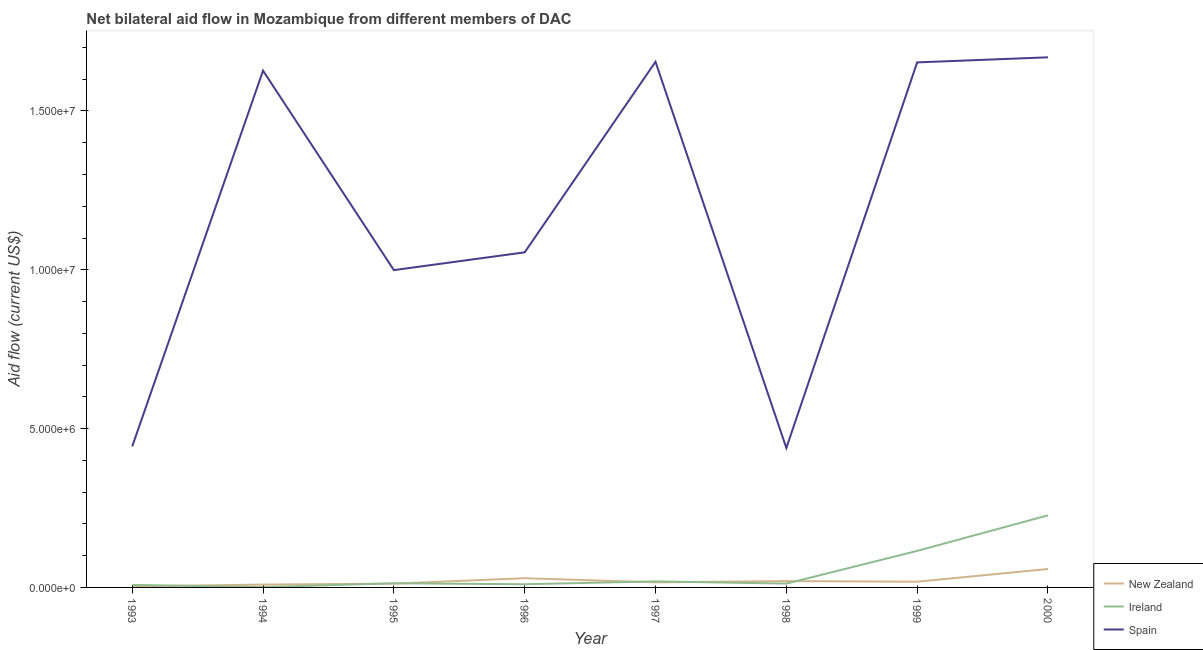Does the line corresponding to amount of aid provided by ireland intersect with the line corresponding to amount of aid provided by spain?
Make the answer very short. No. Is the number of lines equal to the number of legend labels?
Your answer should be compact. Yes. What is the amount of aid provided by spain in 1999?
Ensure brevity in your answer.  1.65e+07. Across all years, what is the maximum amount of aid provided by spain?
Your response must be concise. 1.67e+07. Across all years, what is the minimum amount of aid provided by new zealand?
Ensure brevity in your answer.  3.00e+04. In which year was the amount of aid provided by spain maximum?
Ensure brevity in your answer.  2000. In which year was the amount of aid provided by new zealand minimum?
Provide a succinct answer. 1993. What is the total amount of aid provided by ireland in the graph?
Your answer should be compact. 4.05e+06. What is the difference between the amount of aid provided by spain in 1994 and that in 1997?
Your answer should be compact. -2.80e+05. What is the difference between the amount of aid provided by new zealand in 1999 and the amount of aid provided by ireland in 1996?
Your answer should be very brief. 8.00e+04. What is the average amount of aid provided by spain per year?
Keep it short and to the point. 1.19e+07. In the year 1996, what is the difference between the amount of aid provided by new zealand and amount of aid provided by ireland?
Offer a terse response. 1.90e+05. What is the ratio of the amount of aid provided by spain in 1998 to that in 2000?
Offer a terse response. 0.26. Is the difference between the amount of aid provided by new zealand in 1993 and 1994 greater than the difference between the amount of aid provided by ireland in 1993 and 1994?
Offer a terse response. No. What is the difference between the highest and the lowest amount of aid provided by spain?
Ensure brevity in your answer.  1.23e+07. In how many years, is the amount of aid provided by spain greater than the average amount of aid provided by spain taken over all years?
Your answer should be very brief. 4. Is it the case that in every year, the sum of the amount of aid provided by new zealand and amount of aid provided by ireland is greater than the amount of aid provided by spain?
Provide a succinct answer. No. How many years are there in the graph?
Your answer should be very brief. 8. What is the difference between two consecutive major ticks on the Y-axis?
Make the answer very short. 5.00e+06. How many legend labels are there?
Your answer should be compact. 3. What is the title of the graph?
Keep it short and to the point. Net bilateral aid flow in Mozambique from different members of DAC. Does "Tertiary education" appear as one of the legend labels in the graph?
Give a very brief answer. No. What is the label or title of the Y-axis?
Provide a succinct answer. Aid flow (current US$). What is the Aid flow (current US$) of Spain in 1993?
Offer a terse response. 4.44e+06. What is the Aid flow (current US$) of New Zealand in 1994?
Make the answer very short. 9.00e+04. What is the Aid flow (current US$) in Spain in 1994?
Your answer should be very brief. 1.63e+07. What is the Aid flow (current US$) in New Zealand in 1995?
Your response must be concise. 1.20e+05. What is the Aid flow (current US$) of Spain in 1995?
Ensure brevity in your answer.  9.99e+06. What is the Aid flow (current US$) of Spain in 1996?
Keep it short and to the point. 1.06e+07. What is the Aid flow (current US$) of Spain in 1997?
Keep it short and to the point. 1.66e+07. What is the Aid flow (current US$) in New Zealand in 1998?
Offer a very short reply. 2.00e+05. What is the Aid flow (current US$) in Spain in 1998?
Offer a terse response. 4.39e+06. What is the Aid flow (current US$) in Ireland in 1999?
Offer a terse response. 1.15e+06. What is the Aid flow (current US$) of Spain in 1999?
Keep it short and to the point. 1.65e+07. What is the Aid flow (current US$) in New Zealand in 2000?
Give a very brief answer. 5.80e+05. What is the Aid flow (current US$) in Ireland in 2000?
Your answer should be very brief. 2.27e+06. What is the Aid flow (current US$) in Spain in 2000?
Provide a succinct answer. 1.67e+07. Across all years, what is the maximum Aid flow (current US$) in New Zealand?
Provide a succinct answer. 5.80e+05. Across all years, what is the maximum Aid flow (current US$) of Ireland?
Your answer should be very brief. 2.27e+06. Across all years, what is the maximum Aid flow (current US$) in Spain?
Your response must be concise. 1.67e+07. Across all years, what is the minimum Aid flow (current US$) of Spain?
Your answer should be compact. 4.39e+06. What is the total Aid flow (current US$) in New Zealand in the graph?
Provide a succinct answer. 1.65e+06. What is the total Aid flow (current US$) of Ireland in the graph?
Provide a short and direct response. 4.05e+06. What is the total Aid flow (current US$) of Spain in the graph?
Ensure brevity in your answer.  9.54e+07. What is the difference between the Aid flow (current US$) of Spain in 1993 and that in 1994?
Provide a short and direct response. -1.18e+07. What is the difference between the Aid flow (current US$) in Ireland in 1993 and that in 1995?
Provide a short and direct response. -5.00e+04. What is the difference between the Aid flow (current US$) in Spain in 1993 and that in 1995?
Make the answer very short. -5.55e+06. What is the difference between the Aid flow (current US$) of Spain in 1993 and that in 1996?
Give a very brief answer. -6.11e+06. What is the difference between the Aid flow (current US$) in Ireland in 1993 and that in 1997?
Your answer should be very brief. -1.10e+05. What is the difference between the Aid flow (current US$) of Spain in 1993 and that in 1997?
Provide a short and direct response. -1.21e+07. What is the difference between the Aid flow (current US$) in New Zealand in 1993 and that in 1998?
Offer a very short reply. -1.70e+05. What is the difference between the Aid flow (current US$) of Ireland in 1993 and that in 1998?
Give a very brief answer. -4.00e+04. What is the difference between the Aid flow (current US$) in Ireland in 1993 and that in 1999?
Provide a succinct answer. -1.07e+06. What is the difference between the Aid flow (current US$) in Spain in 1993 and that in 1999?
Ensure brevity in your answer.  -1.21e+07. What is the difference between the Aid flow (current US$) in New Zealand in 1993 and that in 2000?
Provide a short and direct response. -5.50e+05. What is the difference between the Aid flow (current US$) of Ireland in 1993 and that in 2000?
Ensure brevity in your answer.  -2.19e+06. What is the difference between the Aid flow (current US$) of Spain in 1993 and that in 2000?
Offer a terse response. -1.22e+07. What is the difference between the Aid flow (current US$) in New Zealand in 1994 and that in 1995?
Offer a very short reply. -3.00e+04. What is the difference between the Aid flow (current US$) of Ireland in 1994 and that in 1995?
Offer a terse response. -1.20e+05. What is the difference between the Aid flow (current US$) of Spain in 1994 and that in 1995?
Your answer should be very brief. 6.28e+06. What is the difference between the Aid flow (current US$) of Spain in 1994 and that in 1996?
Provide a succinct answer. 5.72e+06. What is the difference between the Aid flow (current US$) in New Zealand in 1994 and that in 1997?
Offer a very short reply. -7.00e+04. What is the difference between the Aid flow (current US$) in Spain in 1994 and that in 1997?
Your answer should be compact. -2.80e+05. What is the difference between the Aid flow (current US$) of Ireland in 1994 and that in 1998?
Provide a succinct answer. -1.10e+05. What is the difference between the Aid flow (current US$) of Spain in 1994 and that in 1998?
Make the answer very short. 1.19e+07. What is the difference between the Aid flow (current US$) in Ireland in 1994 and that in 1999?
Offer a terse response. -1.14e+06. What is the difference between the Aid flow (current US$) in New Zealand in 1994 and that in 2000?
Keep it short and to the point. -4.90e+05. What is the difference between the Aid flow (current US$) of Ireland in 1994 and that in 2000?
Your response must be concise. -2.26e+06. What is the difference between the Aid flow (current US$) of Spain in 1994 and that in 2000?
Your response must be concise. -4.20e+05. What is the difference between the Aid flow (current US$) of Spain in 1995 and that in 1996?
Give a very brief answer. -5.60e+05. What is the difference between the Aid flow (current US$) in New Zealand in 1995 and that in 1997?
Offer a terse response. -4.00e+04. What is the difference between the Aid flow (current US$) in Ireland in 1995 and that in 1997?
Ensure brevity in your answer.  -6.00e+04. What is the difference between the Aid flow (current US$) in Spain in 1995 and that in 1997?
Provide a succinct answer. -6.56e+06. What is the difference between the Aid flow (current US$) of New Zealand in 1995 and that in 1998?
Make the answer very short. -8.00e+04. What is the difference between the Aid flow (current US$) in Spain in 1995 and that in 1998?
Offer a very short reply. 5.60e+06. What is the difference between the Aid flow (current US$) in Ireland in 1995 and that in 1999?
Provide a short and direct response. -1.02e+06. What is the difference between the Aid flow (current US$) in Spain in 1995 and that in 1999?
Your answer should be very brief. -6.54e+06. What is the difference between the Aid flow (current US$) of New Zealand in 1995 and that in 2000?
Your answer should be compact. -4.60e+05. What is the difference between the Aid flow (current US$) of Ireland in 1995 and that in 2000?
Provide a short and direct response. -2.14e+06. What is the difference between the Aid flow (current US$) in Spain in 1995 and that in 2000?
Make the answer very short. -6.70e+06. What is the difference between the Aid flow (current US$) in New Zealand in 1996 and that in 1997?
Give a very brief answer. 1.30e+05. What is the difference between the Aid flow (current US$) in Spain in 1996 and that in 1997?
Your answer should be compact. -6.00e+06. What is the difference between the Aid flow (current US$) in Spain in 1996 and that in 1998?
Your response must be concise. 6.16e+06. What is the difference between the Aid flow (current US$) of New Zealand in 1996 and that in 1999?
Provide a succinct answer. 1.10e+05. What is the difference between the Aid flow (current US$) in Ireland in 1996 and that in 1999?
Your answer should be very brief. -1.05e+06. What is the difference between the Aid flow (current US$) of Spain in 1996 and that in 1999?
Make the answer very short. -5.98e+06. What is the difference between the Aid flow (current US$) of Ireland in 1996 and that in 2000?
Your answer should be very brief. -2.17e+06. What is the difference between the Aid flow (current US$) of Spain in 1996 and that in 2000?
Offer a very short reply. -6.14e+06. What is the difference between the Aid flow (current US$) in New Zealand in 1997 and that in 1998?
Provide a short and direct response. -4.00e+04. What is the difference between the Aid flow (current US$) of Ireland in 1997 and that in 1998?
Make the answer very short. 7.00e+04. What is the difference between the Aid flow (current US$) of Spain in 1997 and that in 1998?
Keep it short and to the point. 1.22e+07. What is the difference between the Aid flow (current US$) in New Zealand in 1997 and that in 1999?
Give a very brief answer. -2.00e+04. What is the difference between the Aid flow (current US$) of Ireland in 1997 and that in 1999?
Offer a terse response. -9.60e+05. What is the difference between the Aid flow (current US$) in New Zealand in 1997 and that in 2000?
Make the answer very short. -4.20e+05. What is the difference between the Aid flow (current US$) in Ireland in 1997 and that in 2000?
Offer a terse response. -2.08e+06. What is the difference between the Aid flow (current US$) in New Zealand in 1998 and that in 1999?
Your answer should be compact. 2.00e+04. What is the difference between the Aid flow (current US$) in Ireland in 1998 and that in 1999?
Give a very brief answer. -1.03e+06. What is the difference between the Aid flow (current US$) of Spain in 1998 and that in 1999?
Offer a very short reply. -1.21e+07. What is the difference between the Aid flow (current US$) in New Zealand in 1998 and that in 2000?
Keep it short and to the point. -3.80e+05. What is the difference between the Aid flow (current US$) in Ireland in 1998 and that in 2000?
Make the answer very short. -2.15e+06. What is the difference between the Aid flow (current US$) of Spain in 1998 and that in 2000?
Provide a short and direct response. -1.23e+07. What is the difference between the Aid flow (current US$) of New Zealand in 1999 and that in 2000?
Make the answer very short. -4.00e+05. What is the difference between the Aid flow (current US$) of Ireland in 1999 and that in 2000?
Offer a terse response. -1.12e+06. What is the difference between the Aid flow (current US$) of Spain in 1999 and that in 2000?
Your response must be concise. -1.60e+05. What is the difference between the Aid flow (current US$) of New Zealand in 1993 and the Aid flow (current US$) of Spain in 1994?
Offer a terse response. -1.62e+07. What is the difference between the Aid flow (current US$) of Ireland in 1993 and the Aid flow (current US$) of Spain in 1994?
Your response must be concise. -1.62e+07. What is the difference between the Aid flow (current US$) of New Zealand in 1993 and the Aid flow (current US$) of Spain in 1995?
Provide a succinct answer. -9.96e+06. What is the difference between the Aid flow (current US$) of Ireland in 1993 and the Aid flow (current US$) of Spain in 1995?
Your answer should be compact. -9.91e+06. What is the difference between the Aid flow (current US$) of New Zealand in 1993 and the Aid flow (current US$) of Spain in 1996?
Your answer should be very brief. -1.05e+07. What is the difference between the Aid flow (current US$) in Ireland in 1993 and the Aid flow (current US$) in Spain in 1996?
Ensure brevity in your answer.  -1.05e+07. What is the difference between the Aid flow (current US$) of New Zealand in 1993 and the Aid flow (current US$) of Ireland in 1997?
Offer a terse response. -1.60e+05. What is the difference between the Aid flow (current US$) in New Zealand in 1993 and the Aid flow (current US$) in Spain in 1997?
Give a very brief answer. -1.65e+07. What is the difference between the Aid flow (current US$) in Ireland in 1993 and the Aid flow (current US$) in Spain in 1997?
Ensure brevity in your answer.  -1.65e+07. What is the difference between the Aid flow (current US$) of New Zealand in 1993 and the Aid flow (current US$) of Ireland in 1998?
Offer a terse response. -9.00e+04. What is the difference between the Aid flow (current US$) of New Zealand in 1993 and the Aid flow (current US$) of Spain in 1998?
Ensure brevity in your answer.  -4.36e+06. What is the difference between the Aid flow (current US$) in Ireland in 1993 and the Aid flow (current US$) in Spain in 1998?
Give a very brief answer. -4.31e+06. What is the difference between the Aid flow (current US$) of New Zealand in 1993 and the Aid flow (current US$) of Ireland in 1999?
Keep it short and to the point. -1.12e+06. What is the difference between the Aid flow (current US$) in New Zealand in 1993 and the Aid flow (current US$) in Spain in 1999?
Your response must be concise. -1.65e+07. What is the difference between the Aid flow (current US$) in Ireland in 1993 and the Aid flow (current US$) in Spain in 1999?
Give a very brief answer. -1.64e+07. What is the difference between the Aid flow (current US$) of New Zealand in 1993 and the Aid flow (current US$) of Ireland in 2000?
Keep it short and to the point. -2.24e+06. What is the difference between the Aid flow (current US$) in New Zealand in 1993 and the Aid flow (current US$) in Spain in 2000?
Provide a short and direct response. -1.67e+07. What is the difference between the Aid flow (current US$) in Ireland in 1993 and the Aid flow (current US$) in Spain in 2000?
Ensure brevity in your answer.  -1.66e+07. What is the difference between the Aid flow (current US$) of New Zealand in 1994 and the Aid flow (current US$) of Spain in 1995?
Your answer should be very brief. -9.90e+06. What is the difference between the Aid flow (current US$) in Ireland in 1994 and the Aid flow (current US$) in Spain in 1995?
Offer a terse response. -9.98e+06. What is the difference between the Aid flow (current US$) of New Zealand in 1994 and the Aid flow (current US$) of Spain in 1996?
Provide a succinct answer. -1.05e+07. What is the difference between the Aid flow (current US$) of Ireland in 1994 and the Aid flow (current US$) of Spain in 1996?
Offer a very short reply. -1.05e+07. What is the difference between the Aid flow (current US$) of New Zealand in 1994 and the Aid flow (current US$) of Ireland in 1997?
Your answer should be compact. -1.00e+05. What is the difference between the Aid flow (current US$) of New Zealand in 1994 and the Aid flow (current US$) of Spain in 1997?
Ensure brevity in your answer.  -1.65e+07. What is the difference between the Aid flow (current US$) of Ireland in 1994 and the Aid flow (current US$) of Spain in 1997?
Your response must be concise. -1.65e+07. What is the difference between the Aid flow (current US$) of New Zealand in 1994 and the Aid flow (current US$) of Ireland in 1998?
Offer a terse response. -3.00e+04. What is the difference between the Aid flow (current US$) of New Zealand in 1994 and the Aid flow (current US$) of Spain in 1998?
Offer a very short reply. -4.30e+06. What is the difference between the Aid flow (current US$) of Ireland in 1994 and the Aid flow (current US$) of Spain in 1998?
Ensure brevity in your answer.  -4.38e+06. What is the difference between the Aid flow (current US$) of New Zealand in 1994 and the Aid flow (current US$) of Ireland in 1999?
Your response must be concise. -1.06e+06. What is the difference between the Aid flow (current US$) of New Zealand in 1994 and the Aid flow (current US$) of Spain in 1999?
Give a very brief answer. -1.64e+07. What is the difference between the Aid flow (current US$) in Ireland in 1994 and the Aid flow (current US$) in Spain in 1999?
Your response must be concise. -1.65e+07. What is the difference between the Aid flow (current US$) in New Zealand in 1994 and the Aid flow (current US$) in Ireland in 2000?
Offer a terse response. -2.18e+06. What is the difference between the Aid flow (current US$) in New Zealand in 1994 and the Aid flow (current US$) in Spain in 2000?
Your response must be concise. -1.66e+07. What is the difference between the Aid flow (current US$) of Ireland in 1994 and the Aid flow (current US$) of Spain in 2000?
Offer a very short reply. -1.67e+07. What is the difference between the Aid flow (current US$) of New Zealand in 1995 and the Aid flow (current US$) of Spain in 1996?
Keep it short and to the point. -1.04e+07. What is the difference between the Aid flow (current US$) of Ireland in 1995 and the Aid flow (current US$) of Spain in 1996?
Your answer should be compact. -1.04e+07. What is the difference between the Aid flow (current US$) in New Zealand in 1995 and the Aid flow (current US$) in Spain in 1997?
Offer a very short reply. -1.64e+07. What is the difference between the Aid flow (current US$) of Ireland in 1995 and the Aid flow (current US$) of Spain in 1997?
Your answer should be compact. -1.64e+07. What is the difference between the Aid flow (current US$) of New Zealand in 1995 and the Aid flow (current US$) of Ireland in 1998?
Offer a very short reply. 0. What is the difference between the Aid flow (current US$) of New Zealand in 1995 and the Aid flow (current US$) of Spain in 1998?
Provide a short and direct response. -4.27e+06. What is the difference between the Aid flow (current US$) in Ireland in 1995 and the Aid flow (current US$) in Spain in 1998?
Ensure brevity in your answer.  -4.26e+06. What is the difference between the Aid flow (current US$) in New Zealand in 1995 and the Aid flow (current US$) in Ireland in 1999?
Your answer should be very brief. -1.03e+06. What is the difference between the Aid flow (current US$) in New Zealand in 1995 and the Aid flow (current US$) in Spain in 1999?
Provide a short and direct response. -1.64e+07. What is the difference between the Aid flow (current US$) of Ireland in 1995 and the Aid flow (current US$) of Spain in 1999?
Keep it short and to the point. -1.64e+07. What is the difference between the Aid flow (current US$) in New Zealand in 1995 and the Aid flow (current US$) in Ireland in 2000?
Provide a succinct answer. -2.15e+06. What is the difference between the Aid flow (current US$) in New Zealand in 1995 and the Aid flow (current US$) in Spain in 2000?
Provide a short and direct response. -1.66e+07. What is the difference between the Aid flow (current US$) of Ireland in 1995 and the Aid flow (current US$) of Spain in 2000?
Make the answer very short. -1.66e+07. What is the difference between the Aid flow (current US$) in New Zealand in 1996 and the Aid flow (current US$) in Ireland in 1997?
Your answer should be compact. 1.00e+05. What is the difference between the Aid flow (current US$) in New Zealand in 1996 and the Aid flow (current US$) in Spain in 1997?
Give a very brief answer. -1.63e+07. What is the difference between the Aid flow (current US$) of Ireland in 1996 and the Aid flow (current US$) of Spain in 1997?
Your response must be concise. -1.64e+07. What is the difference between the Aid flow (current US$) in New Zealand in 1996 and the Aid flow (current US$) in Ireland in 1998?
Make the answer very short. 1.70e+05. What is the difference between the Aid flow (current US$) in New Zealand in 1996 and the Aid flow (current US$) in Spain in 1998?
Your response must be concise. -4.10e+06. What is the difference between the Aid flow (current US$) in Ireland in 1996 and the Aid flow (current US$) in Spain in 1998?
Ensure brevity in your answer.  -4.29e+06. What is the difference between the Aid flow (current US$) in New Zealand in 1996 and the Aid flow (current US$) in Ireland in 1999?
Offer a very short reply. -8.60e+05. What is the difference between the Aid flow (current US$) of New Zealand in 1996 and the Aid flow (current US$) of Spain in 1999?
Your response must be concise. -1.62e+07. What is the difference between the Aid flow (current US$) of Ireland in 1996 and the Aid flow (current US$) of Spain in 1999?
Your response must be concise. -1.64e+07. What is the difference between the Aid flow (current US$) in New Zealand in 1996 and the Aid flow (current US$) in Ireland in 2000?
Keep it short and to the point. -1.98e+06. What is the difference between the Aid flow (current US$) of New Zealand in 1996 and the Aid flow (current US$) of Spain in 2000?
Your response must be concise. -1.64e+07. What is the difference between the Aid flow (current US$) in Ireland in 1996 and the Aid flow (current US$) in Spain in 2000?
Provide a short and direct response. -1.66e+07. What is the difference between the Aid flow (current US$) of New Zealand in 1997 and the Aid flow (current US$) of Spain in 1998?
Provide a short and direct response. -4.23e+06. What is the difference between the Aid flow (current US$) of Ireland in 1997 and the Aid flow (current US$) of Spain in 1998?
Your response must be concise. -4.20e+06. What is the difference between the Aid flow (current US$) of New Zealand in 1997 and the Aid flow (current US$) of Ireland in 1999?
Your answer should be very brief. -9.90e+05. What is the difference between the Aid flow (current US$) in New Zealand in 1997 and the Aid flow (current US$) in Spain in 1999?
Offer a very short reply. -1.64e+07. What is the difference between the Aid flow (current US$) of Ireland in 1997 and the Aid flow (current US$) of Spain in 1999?
Your response must be concise. -1.63e+07. What is the difference between the Aid flow (current US$) in New Zealand in 1997 and the Aid flow (current US$) in Ireland in 2000?
Your response must be concise. -2.11e+06. What is the difference between the Aid flow (current US$) in New Zealand in 1997 and the Aid flow (current US$) in Spain in 2000?
Make the answer very short. -1.65e+07. What is the difference between the Aid flow (current US$) of Ireland in 1997 and the Aid flow (current US$) of Spain in 2000?
Your answer should be very brief. -1.65e+07. What is the difference between the Aid flow (current US$) in New Zealand in 1998 and the Aid flow (current US$) in Ireland in 1999?
Provide a short and direct response. -9.50e+05. What is the difference between the Aid flow (current US$) in New Zealand in 1998 and the Aid flow (current US$) in Spain in 1999?
Provide a succinct answer. -1.63e+07. What is the difference between the Aid flow (current US$) of Ireland in 1998 and the Aid flow (current US$) of Spain in 1999?
Provide a succinct answer. -1.64e+07. What is the difference between the Aid flow (current US$) of New Zealand in 1998 and the Aid flow (current US$) of Ireland in 2000?
Your response must be concise. -2.07e+06. What is the difference between the Aid flow (current US$) of New Zealand in 1998 and the Aid flow (current US$) of Spain in 2000?
Provide a short and direct response. -1.65e+07. What is the difference between the Aid flow (current US$) in Ireland in 1998 and the Aid flow (current US$) in Spain in 2000?
Provide a short and direct response. -1.66e+07. What is the difference between the Aid flow (current US$) of New Zealand in 1999 and the Aid flow (current US$) of Ireland in 2000?
Your response must be concise. -2.09e+06. What is the difference between the Aid flow (current US$) of New Zealand in 1999 and the Aid flow (current US$) of Spain in 2000?
Provide a short and direct response. -1.65e+07. What is the difference between the Aid flow (current US$) of Ireland in 1999 and the Aid flow (current US$) of Spain in 2000?
Your answer should be very brief. -1.55e+07. What is the average Aid flow (current US$) of New Zealand per year?
Keep it short and to the point. 2.06e+05. What is the average Aid flow (current US$) in Ireland per year?
Offer a terse response. 5.06e+05. What is the average Aid flow (current US$) of Spain per year?
Provide a short and direct response. 1.19e+07. In the year 1993, what is the difference between the Aid flow (current US$) in New Zealand and Aid flow (current US$) in Ireland?
Provide a short and direct response. -5.00e+04. In the year 1993, what is the difference between the Aid flow (current US$) of New Zealand and Aid flow (current US$) of Spain?
Your response must be concise. -4.41e+06. In the year 1993, what is the difference between the Aid flow (current US$) of Ireland and Aid flow (current US$) of Spain?
Your response must be concise. -4.36e+06. In the year 1994, what is the difference between the Aid flow (current US$) in New Zealand and Aid flow (current US$) in Spain?
Your answer should be very brief. -1.62e+07. In the year 1994, what is the difference between the Aid flow (current US$) of Ireland and Aid flow (current US$) of Spain?
Provide a succinct answer. -1.63e+07. In the year 1995, what is the difference between the Aid flow (current US$) in New Zealand and Aid flow (current US$) in Ireland?
Offer a terse response. -10000. In the year 1995, what is the difference between the Aid flow (current US$) in New Zealand and Aid flow (current US$) in Spain?
Offer a very short reply. -9.87e+06. In the year 1995, what is the difference between the Aid flow (current US$) of Ireland and Aid flow (current US$) of Spain?
Provide a short and direct response. -9.86e+06. In the year 1996, what is the difference between the Aid flow (current US$) of New Zealand and Aid flow (current US$) of Spain?
Provide a short and direct response. -1.03e+07. In the year 1996, what is the difference between the Aid flow (current US$) of Ireland and Aid flow (current US$) of Spain?
Provide a short and direct response. -1.04e+07. In the year 1997, what is the difference between the Aid flow (current US$) in New Zealand and Aid flow (current US$) in Spain?
Provide a short and direct response. -1.64e+07. In the year 1997, what is the difference between the Aid flow (current US$) of Ireland and Aid flow (current US$) of Spain?
Ensure brevity in your answer.  -1.64e+07. In the year 1998, what is the difference between the Aid flow (current US$) of New Zealand and Aid flow (current US$) of Ireland?
Keep it short and to the point. 8.00e+04. In the year 1998, what is the difference between the Aid flow (current US$) in New Zealand and Aid flow (current US$) in Spain?
Offer a very short reply. -4.19e+06. In the year 1998, what is the difference between the Aid flow (current US$) of Ireland and Aid flow (current US$) of Spain?
Provide a succinct answer. -4.27e+06. In the year 1999, what is the difference between the Aid flow (current US$) in New Zealand and Aid flow (current US$) in Ireland?
Give a very brief answer. -9.70e+05. In the year 1999, what is the difference between the Aid flow (current US$) in New Zealand and Aid flow (current US$) in Spain?
Ensure brevity in your answer.  -1.64e+07. In the year 1999, what is the difference between the Aid flow (current US$) in Ireland and Aid flow (current US$) in Spain?
Offer a terse response. -1.54e+07. In the year 2000, what is the difference between the Aid flow (current US$) of New Zealand and Aid flow (current US$) of Ireland?
Offer a terse response. -1.69e+06. In the year 2000, what is the difference between the Aid flow (current US$) in New Zealand and Aid flow (current US$) in Spain?
Make the answer very short. -1.61e+07. In the year 2000, what is the difference between the Aid flow (current US$) of Ireland and Aid flow (current US$) of Spain?
Provide a short and direct response. -1.44e+07. What is the ratio of the Aid flow (current US$) of Ireland in 1993 to that in 1994?
Give a very brief answer. 8. What is the ratio of the Aid flow (current US$) in Spain in 1993 to that in 1994?
Offer a terse response. 0.27. What is the ratio of the Aid flow (current US$) of Ireland in 1993 to that in 1995?
Offer a very short reply. 0.62. What is the ratio of the Aid flow (current US$) of Spain in 1993 to that in 1995?
Make the answer very short. 0.44. What is the ratio of the Aid flow (current US$) in New Zealand in 1993 to that in 1996?
Your answer should be very brief. 0.1. What is the ratio of the Aid flow (current US$) of Ireland in 1993 to that in 1996?
Keep it short and to the point. 0.8. What is the ratio of the Aid flow (current US$) of Spain in 1993 to that in 1996?
Offer a terse response. 0.42. What is the ratio of the Aid flow (current US$) of New Zealand in 1993 to that in 1997?
Offer a very short reply. 0.19. What is the ratio of the Aid flow (current US$) in Ireland in 1993 to that in 1997?
Offer a terse response. 0.42. What is the ratio of the Aid flow (current US$) of Spain in 1993 to that in 1997?
Keep it short and to the point. 0.27. What is the ratio of the Aid flow (current US$) in Ireland in 1993 to that in 1998?
Provide a succinct answer. 0.67. What is the ratio of the Aid flow (current US$) of Spain in 1993 to that in 1998?
Keep it short and to the point. 1.01. What is the ratio of the Aid flow (current US$) in New Zealand in 1993 to that in 1999?
Ensure brevity in your answer.  0.17. What is the ratio of the Aid flow (current US$) in Ireland in 1993 to that in 1999?
Your response must be concise. 0.07. What is the ratio of the Aid flow (current US$) in Spain in 1993 to that in 1999?
Give a very brief answer. 0.27. What is the ratio of the Aid flow (current US$) of New Zealand in 1993 to that in 2000?
Give a very brief answer. 0.05. What is the ratio of the Aid flow (current US$) in Ireland in 1993 to that in 2000?
Offer a terse response. 0.04. What is the ratio of the Aid flow (current US$) in Spain in 1993 to that in 2000?
Give a very brief answer. 0.27. What is the ratio of the Aid flow (current US$) in Ireland in 1994 to that in 1995?
Offer a terse response. 0.08. What is the ratio of the Aid flow (current US$) in Spain in 1994 to that in 1995?
Keep it short and to the point. 1.63. What is the ratio of the Aid flow (current US$) of New Zealand in 1994 to that in 1996?
Ensure brevity in your answer.  0.31. What is the ratio of the Aid flow (current US$) in Spain in 1994 to that in 1996?
Ensure brevity in your answer.  1.54. What is the ratio of the Aid flow (current US$) of New Zealand in 1994 to that in 1997?
Offer a very short reply. 0.56. What is the ratio of the Aid flow (current US$) in Ireland in 1994 to that in 1997?
Your answer should be very brief. 0.05. What is the ratio of the Aid flow (current US$) of Spain in 1994 to that in 1997?
Your response must be concise. 0.98. What is the ratio of the Aid flow (current US$) of New Zealand in 1994 to that in 1998?
Your answer should be compact. 0.45. What is the ratio of the Aid flow (current US$) of Ireland in 1994 to that in 1998?
Offer a very short reply. 0.08. What is the ratio of the Aid flow (current US$) in Spain in 1994 to that in 1998?
Ensure brevity in your answer.  3.71. What is the ratio of the Aid flow (current US$) in Ireland in 1994 to that in 1999?
Ensure brevity in your answer.  0.01. What is the ratio of the Aid flow (current US$) in Spain in 1994 to that in 1999?
Your answer should be very brief. 0.98. What is the ratio of the Aid flow (current US$) of New Zealand in 1994 to that in 2000?
Keep it short and to the point. 0.16. What is the ratio of the Aid flow (current US$) in Ireland in 1994 to that in 2000?
Offer a terse response. 0. What is the ratio of the Aid flow (current US$) in Spain in 1994 to that in 2000?
Provide a short and direct response. 0.97. What is the ratio of the Aid flow (current US$) of New Zealand in 1995 to that in 1996?
Offer a very short reply. 0.41. What is the ratio of the Aid flow (current US$) in Spain in 1995 to that in 1996?
Your answer should be very brief. 0.95. What is the ratio of the Aid flow (current US$) in New Zealand in 1995 to that in 1997?
Your answer should be compact. 0.75. What is the ratio of the Aid flow (current US$) in Ireland in 1995 to that in 1997?
Your answer should be compact. 0.68. What is the ratio of the Aid flow (current US$) of Spain in 1995 to that in 1997?
Your response must be concise. 0.6. What is the ratio of the Aid flow (current US$) of Spain in 1995 to that in 1998?
Offer a terse response. 2.28. What is the ratio of the Aid flow (current US$) of Ireland in 1995 to that in 1999?
Your answer should be very brief. 0.11. What is the ratio of the Aid flow (current US$) in Spain in 1995 to that in 1999?
Give a very brief answer. 0.6. What is the ratio of the Aid flow (current US$) in New Zealand in 1995 to that in 2000?
Provide a succinct answer. 0.21. What is the ratio of the Aid flow (current US$) in Ireland in 1995 to that in 2000?
Your answer should be compact. 0.06. What is the ratio of the Aid flow (current US$) in Spain in 1995 to that in 2000?
Give a very brief answer. 0.6. What is the ratio of the Aid flow (current US$) in New Zealand in 1996 to that in 1997?
Offer a very short reply. 1.81. What is the ratio of the Aid flow (current US$) of Ireland in 1996 to that in 1997?
Keep it short and to the point. 0.53. What is the ratio of the Aid flow (current US$) in Spain in 1996 to that in 1997?
Your answer should be very brief. 0.64. What is the ratio of the Aid flow (current US$) of New Zealand in 1996 to that in 1998?
Provide a short and direct response. 1.45. What is the ratio of the Aid flow (current US$) in Spain in 1996 to that in 1998?
Make the answer very short. 2.4. What is the ratio of the Aid flow (current US$) of New Zealand in 1996 to that in 1999?
Provide a succinct answer. 1.61. What is the ratio of the Aid flow (current US$) of Ireland in 1996 to that in 1999?
Offer a terse response. 0.09. What is the ratio of the Aid flow (current US$) of Spain in 1996 to that in 1999?
Make the answer very short. 0.64. What is the ratio of the Aid flow (current US$) in New Zealand in 1996 to that in 2000?
Offer a very short reply. 0.5. What is the ratio of the Aid flow (current US$) in Ireland in 1996 to that in 2000?
Offer a terse response. 0.04. What is the ratio of the Aid flow (current US$) of Spain in 1996 to that in 2000?
Your answer should be compact. 0.63. What is the ratio of the Aid flow (current US$) of Ireland in 1997 to that in 1998?
Provide a succinct answer. 1.58. What is the ratio of the Aid flow (current US$) of Spain in 1997 to that in 1998?
Offer a terse response. 3.77. What is the ratio of the Aid flow (current US$) in New Zealand in 1997 to that in 1999?
Offer a very short reply. 0.89. What is the ratio of the Aid flow (current US$) of Ireland in 1997 to that in 1999?
Your response must be concise. 0.17. What is the ratio of the Aid flow (current US$) in New Zealand in 1997 to that in 2000?
Your response must be concise. 0.28. What is the ratio of the Aid flow (current US$) of Ireland in 1997 to that in 2000?
Give a very brief answer. 0.08. What is the ratio of the Aid flow (current US$) in New Zealand in 1998 to that in 1999?
Make the answer very short. 1.11. What is the ratio of the Aid flow (current US$) in Ireland in 1998 to that in 1999?
Offer a terse response. 0.1. What is the ratio of the Aid flow (current US$) in Spain in 1998 to that in 1999?
Your response must be concise. 0.27. What is the ratio of the Aid flow (current US$) in New Zealand in 1998 to that in 2000?
Provide a short and direct response. 0.34. What is the ratio of the Aid flow (current US$) of Ireland in 1998 to that in 2000?
Provide a succinct answer. 0.05. What is the ratio of the Aid flow (current US$) in Spain in 1998 to that in 2000?
Offer a very short reply. 0.26. What is the ratio of the Aid flow (current US$) of New Zealand in 1999 to that in 2000?
Keep it short and to the point. 0.31. What is the ratio of the Aid flow (current US$) of Ireland in 1999 to that in 2000?
Your answer should be very brief. 0.51. What is the ratio of the Aid flow (current US$) of Spain in 1999 to that in 2000?
Make the answer very short. 0.99. What is the difference between the highest and the second highest Aid flow (current US$) in Ireland?
Offer a very short reply. 1.12e+06. What is the difference between the highest and the lowest Aid flow (current US$) of New Zealand?
Your answer should be compact. 5.50e+05. What is the difference between the highest and the lowest Aid flow (current US$) in Ireland?
Keep it short and to the point. 2.26e+06. What is the difference between the highest and the lowest Aid flow (current US$) of Spain?
Keep it short and to the point. 1.23e+07. 